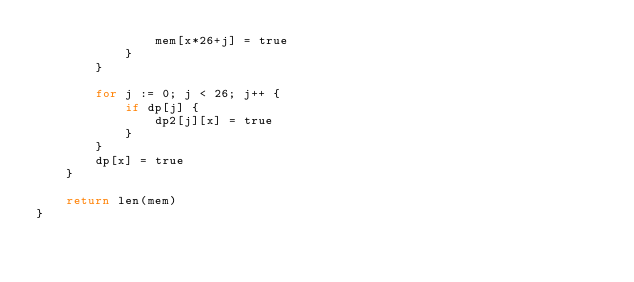Convert code to text. <code><loc_0><loc_0><loc_500><loc_500><_Go_>				mem[x*26+j] = true
			}
		}

		for j := 0; j < 26; j++ {
			if dp[j] {
				dp2[j][x] = true
			}
		}
		dp[x] = true
	}

	return len(mem)
}
</code> 